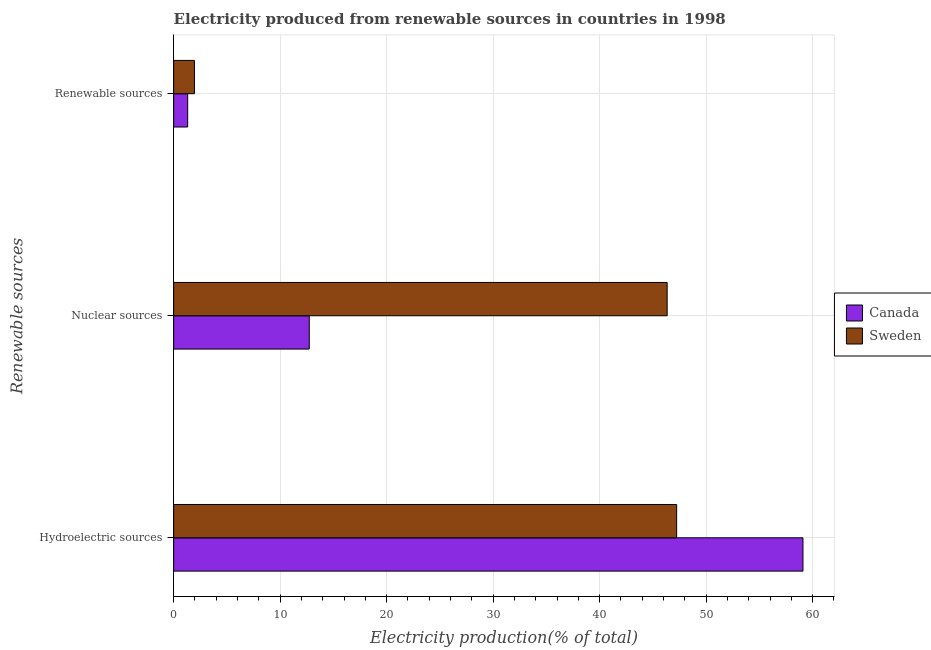How many different coloured bars are there?
Offer a very short reply. 2. Are the number of bars per tick equal to the number of legend labels?
Your answer should be compact. Yes. Are the number of bars on each tick of the Y-axis equal?
Offer a terse response. Yes. How many bars are there on the 2nd tick from the top?
Your response must be concise. 2. How many bars are there on the 2nd tick from the bottom?
Provide a succinct answer. 2. What is the label of the 2nd group of bars from the top?
Ensure brevity in your answer.  Nuclear sources. What is the percentage of electricity produced by nuclear sources in Canada?
Provide a short and direct response. 12.73. Across all countries, what is the maximum percentage of electricity produced by hydroelectric sources?
Your answer should be very brief. 59.09. Across all countries, what is the minimum percentage of electricity produced by hydroelectric sources?
Keep it short and to the point. 47.23. In which country was the percentage of electricity produced by nuclear sources maximum?
Keep it short and to the point. Sweden. In which country was the percentage of electricity produced by renewable sources minimum?
Your response must be concise. Canada. What is the total percentage of electricity produced by nuclear sources in the graph?
Ensure brevity in your answer.  59.07. What is the difference between the percentage of electricity produced by nuclear sources in Sweden and that in Canada?
Keep it short and to the point. 33.61. What is the difference between the percentage of electricity produced by hydroelectric sources in Sweden and the percentage of electricity produced by renewable sources in Canada?
Offer a very short reply. 45.92. What is the average percentage of electricity produced by renewable sources per country?
Provide a short and direct response. 1.63. What is the difference between the percentage of electricity produced by renewable sources and percentage of electricity produced by nuclear sources in Canada?
Offer a terse response. -11.42. What is the ratio of the percentage of electricity produced by hydroelectric sources in Canada to that in Sweden?
Make the answer very short. 1.25. Is the percentage of electricity produced by renewable sources in Canada less than that in Sweden?
Your answer should be compact. Yes. What is the difference between the highest and the second highest percentage of electricity produced by renewable sources?
Provide a succinct answer. 0.64. What is the difference between the highest and the lowest percentage of electricity produced by hydroelectric sources?
Your response must be concise. 11.86. Is the sum of the percentage of electricity produced by renewable sources in Canada and Sweden greater than the maximum percentage of electricity produced by hydroelectric sources across all countries?
Your answer should be compact. No. What does the 2nd bar from the bottom in Renewable sources represents?
Your answer should be very brief. Sweden. How many bars are there?
Ensure brevity in your answer.  6. How many countries are there in the graph?
Offer a very short reply. 2. Are the values on the major ticks of X-axis written in scientific E-notation?
Offer a terse response. No. Does the graph contain grids?
Ensure brevity in your answer.  Yes. Where does the legend appear in the graph?
Provide a short and direct response. Center right. What is the title of the graph?
Provide a succinct answer. Electricity produced from renewable sources in countries in 1998. Does "Central Europe" appear as one of the legend labels in the graph?
Provide a short and direct response. No. What is the label or title of the X-axis?
Keep it short and to the point. Electricity production(% of total). What is the label or title of the Y-axis?
Give a very brief answer. Renewable sources. What is the Electricity production(% of total) in Canada in Hydroelectric sources?
Offer a very short reply. 59.09. What is the Electricity production(% of total) of Sweden in Hydroelectric sources?
Offer a terse response. 47.23. What is the Electricity production(% of total) in Canada in Nuclear sources?
Make the answer very short. 12.73. What is the Electricity production(% of total) in Sweden in Nuclear sources?
Keep it short and to the point. 46.34. What is the Electricity production(% of total) in Canada in Renewable sources?
Your answer should be compact. 1.31. What is the Electricity production(% of total) of Sweden in Renewable sources?
Provide a succinct answer. 1.95. Across all Renewable sources, what is the maximum Electricity production(% of total) of Canada?
Offer a terse response. 59.09. Across all Renewable sources, what is the maximum Electricity production(% of total) in Sweden?
Keep it short and to the point. 47.23. Across all Renewable sources, what is the minimum Electricity production(% of total) in Canada?
Provide a succinct answer. 1.31. Across all Renewable sources, what is the minimum Electricity production(% of total) of Sweden?
Offer a terse response. 1.95. What is the total Electricity production(% of total) in Canada in the graph?
Provide a short and direct response. 73.14. What is the total Electricity production(% of total) in Sweden in the graph?
Your answer should be compact. 95.52. What is the difference between the Electricity production(% of total) in Canada in Hydroelectric sources and that in Nuclear sources?
Offer a very short reply. 46.36. What is the difference between the Electricity production(% of total) in Sweden in Hydroelectric sources and that in Nuclear sources?
Ensure brevity in your answer.  0.89. What is the difference between the Electricity production(% of total) in Canada in Hydroelectric sources and that in Renewable sources?
Offer a terse response. 57.78. What is the difference between the Electricity production(% of total) of Sweden in Hydroelectric sources and that in Renewable sources?
Ensure brevity in your answer.  45.28. What is the difference between the Electricity production(% of total) in Canada in Nuclear sources and that in Renewable sources?
Your answer should be very brief. 11.42. What is the difference between the Electricity production(% of total) of Sweden in Nuclear sources and that in Renewable sources?
Your answer should be compact. 44.39. What is the difference between the Electricity production(% of total) in Canada in Hydroelectric sources and the Electricity production(% of total) in Sweden in Nuclear sources?
Offer a very short reply. 12.75. What is the difference between the Electricity production(% of total) in Canada in Hydroelectric sources and the Electricity production(% of total) in Sweden in Renewable sources?
Ensure brevity in your answer.  57.14. What is the difference between the Electricity production(% of total) in Canada in Nuclear sources and the Electricity production(% of total) in Sweden in Renewable sources?
Your answer should be compact. 10.78. What is the average Electricity production(% of total) in Canada per Renewable sources?
Your answer should be compact. 24.38. What is the average Electricity production(% of total) of Sweden per Renewable sources?
Make the answer very short. 31.84. What is the difference between the Electricity production(% of total) in Canada and Electricity production(% of total) in Sweden in Hydroelectric sources?
Offer a terse response. 11.86. What is the difference between the Electricity production(% of total) in Canada and Electricity production(% of total) in Sweden in Nuclear sources?
Give a very brief answer. -33.61. What is the difference between the Electricity production(% of total) of Canada and Electricity production(% of total) of Sweden in Renewable sources?
Offer a terse response. -0.64. What is the ratio of the Electricity production(% of total) of Canada in Hydroelectric sources to that in Nuclear sources?
Your answer should be compact. 4.64. What is the ratio of the Electricity production(% of total) of Sweden in Hydroelectric sources to that in Nuclear sources?
Your response must be concise. 1.02. What is the ratio of the Electricity production(% of total) of Canada in Hydroelectric sources to that in Renewable sources?
Make the answer very short. 44.97. What is the ratio of the Electricity production(% of total) of Sweden in Hydroelectric sources to that in Renewable sources?
Your answer should be very brief. 24.21. What is the ratio of the Electricity production(% of total) of Canada in Nuclear sources to that in Renewable sources?
Your response must be concise. 9.69. What is the ratio of the Electricity production(% of total) of Sweden in Nuclear sources to that in Renewable sources?
Offer a very short reply. 23.75. What is the difference between the highest and the second highest Electricity production(% of total) in Canada?
Provide a succinct answer. 46.36. What is the difference between the highest and the second highest Electricity production(% of total) in Sweden?
Make the answer very short. 0.89. What is the difference between the highest and the lowest Electricity production(% of total) of Canada?
Give a very brief answer. 57.78. What is the difference between the highest and the lowest Electricity production(% of total) of Sweden?
Your answer should be very brief. 45.28. 